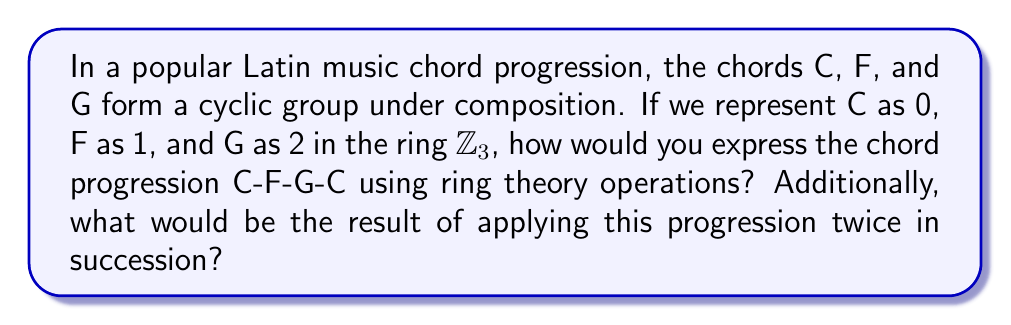Can you solve this math problem? To approach this problem, we'll use concepts from ring theory and group theory:

1) First, let's establish our mapping:
   C → 0
   F → 1
   G → 2

2) In $\mathbb{Z}_3$, addition is performed modulo 3. So, 0 + 1 = 1, 1 + 1 = 2, 2 + 1 = 0, and so on.

3) The chord progression C-F-G-C can be represented as a sequence of additions in $\mathbb{Z}_3$:

   $0 \rightarrow 0+1 \rightarrow 1+1 \rightarrow 2+1$

4) Let's perform these operations:
   
   $0 \rightarrow 1 \rightarrow 2 \rightarrow 0$

5) This sequence can be expressed as the repeated application of the operation "+1 mod 3".

6) In ring theory notation, we can write this as:

   $x \mapsto x+1 \pmod{3}$

7) To apply this progression twice in succession, we would perform this operation 8 times (as the original progression has 4 chords).

8) Mathematically, this is equivalent to adding 8 to our starting point:

   $x \mapsto x+8 \pmod{3}$

9) Since 8 ≡ 2 (mod 3), this is the same as:

   $x \mapsto x+2 \pmod{3}$

10) Applying this to our starting chord (C, represented by 0):

    $0 \mapsto 0+2 \pmod{3} = 2$

11) 2 in our original mapping corresponds to the chord G.
Answer: The chord progression C-F-G-C can be expressed in ring theory as the operation $x \mapsto x+1 \pmod{3}$ in $\mathbb{Z}_3$. Applying this progression twice in succession results in the operation $x \mapsto x+2 \pmod{3}$, which when applied to the starting chord C (0) results in G (2). 